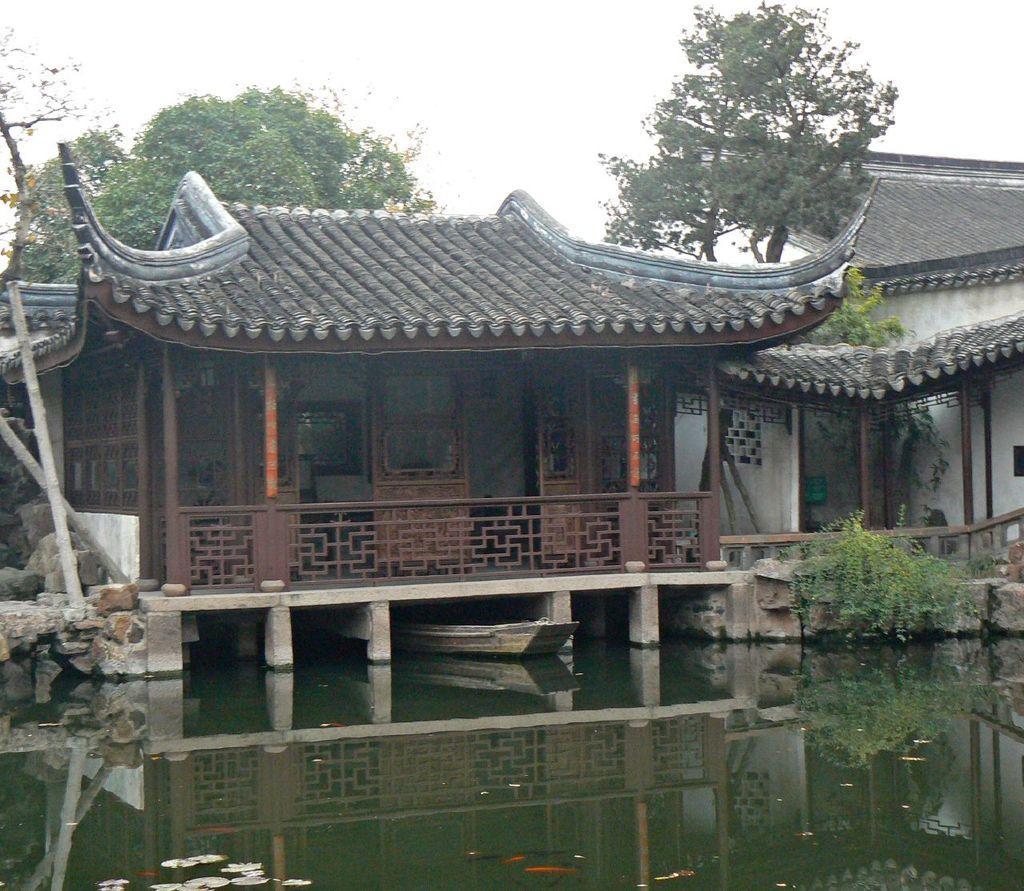In one or two sentences, can you explain what this image depicts? In this picture we can see few houses, trees, rocks and a boat on the water. 